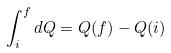<formula> <loc_0><loc_0><loc_500><loc_500>\int _ { i } ^ { f } d Q = Q ( f ) - Q ( i )</formula> 